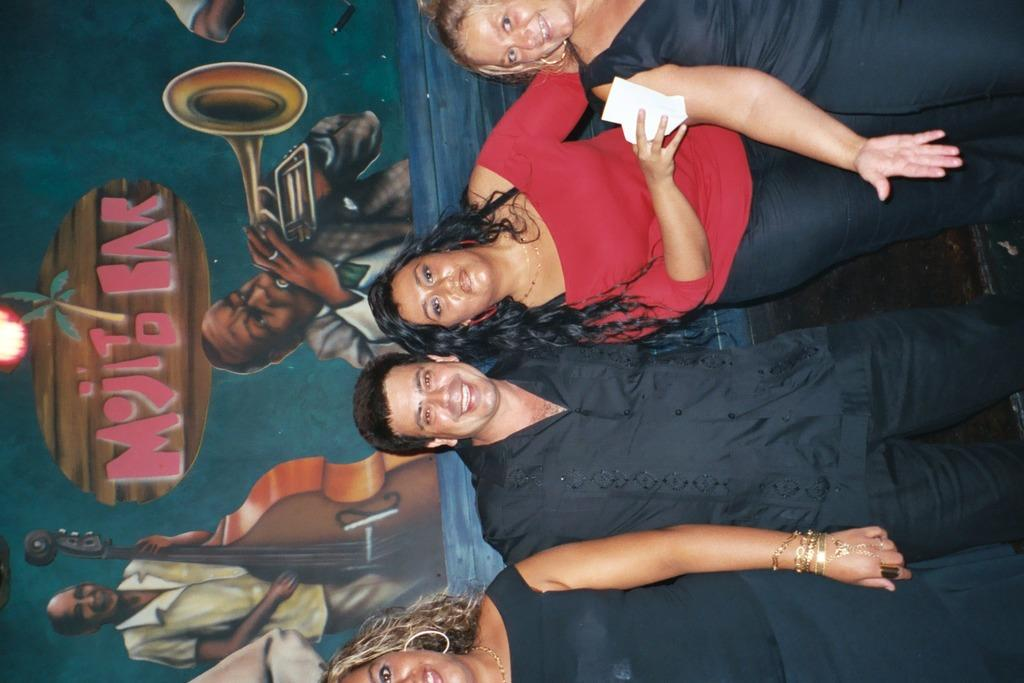How many people are in the image? There are persons in the image, but the exact number is not specified. What are the persons wearing? The persons are wearing clothes. What can be seen in the background of the image? There is a wall in the background of the image. What is on the wall in the image? The wall contains an art piece. Where is the nearest hydrant to the persons in the image? There is no information about a hydrant in the image or its surroundings, so it cannot be determined. 